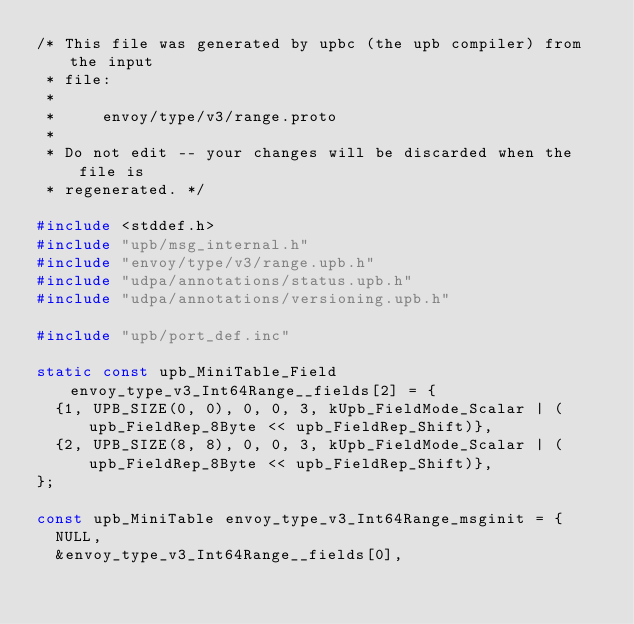<code> <loc_0><loc_0><loc_500><loc_500><_C_>/* This file was generated by upbc (the upb compiler) from the input
 * file:
 *
 *     envoy/type/v3/range.proto
 *
 * Do not edit -- your changes will be discarded when the file is
 * regenerated. */

#include <stddef.h>
#include "upb/msg_internal.h"
#include "envoy/type/v3/range.upb.h"
#include "udpa/annotations/status.upb.h"
#include "udpa/annotations/versioning.upb.h"

#include "upb/port_def.inc"

static const upb_MiniTable_Field envoy_type_v3_Int64Range__fields[2] = {
  {1, UPB_SIZE(0, 0), 0, 0, 3, kUpb_FieldMode_Scalar | (upb_FieldRep_8Byte << upb_FieldRep_Shift)},
  {2, UPB_SIZE(8, 8), 0, 0, 3, kUpb_FieldMode_Scalar | (upb_FieldRep_8Byte << upb_FieldRep_Shift)},
};

const upb_MiniTable envoy_type_v3_Int64Range_msginit = {
  NULL,
  &envoy_type_v3_Int64Range__fields[0],</code> 